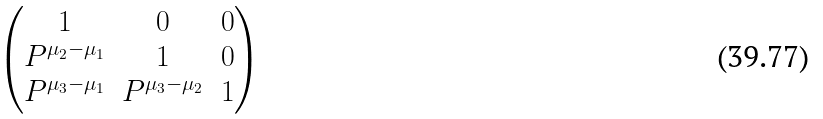<formula> <loc_0><loc_0><loc_500><loc_500>\begin{pmatrix} 1 & 0 & 0 \\ P ^ { \mu _ { 2 } - \mu _ { 1 } } & 1 & 0 \\ P ^ { \mu _ { 3 } - \mu _ { 1 } } & P ^ { \mu _ { 3 } - \mu _ { 2 } } & 1 \end{pmatrix}</formula> 